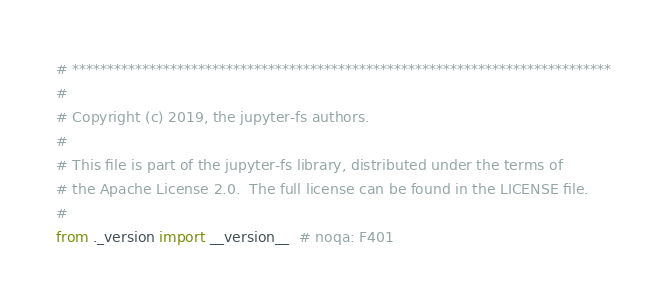Convert code to text. <code><loc_0><loc_0><loc_500><loc_500><_Python_># *****************************************************************************
#
# Copyright (c) 2019, the jupyter-fs authors.
#
# This file is part of the jupyter-fs library, distributed under the terms of
# the Apache License 2.0.  The full license can be found in the LICENSE file.
#
from ._version import __version__  # noqa: F401
</code> 